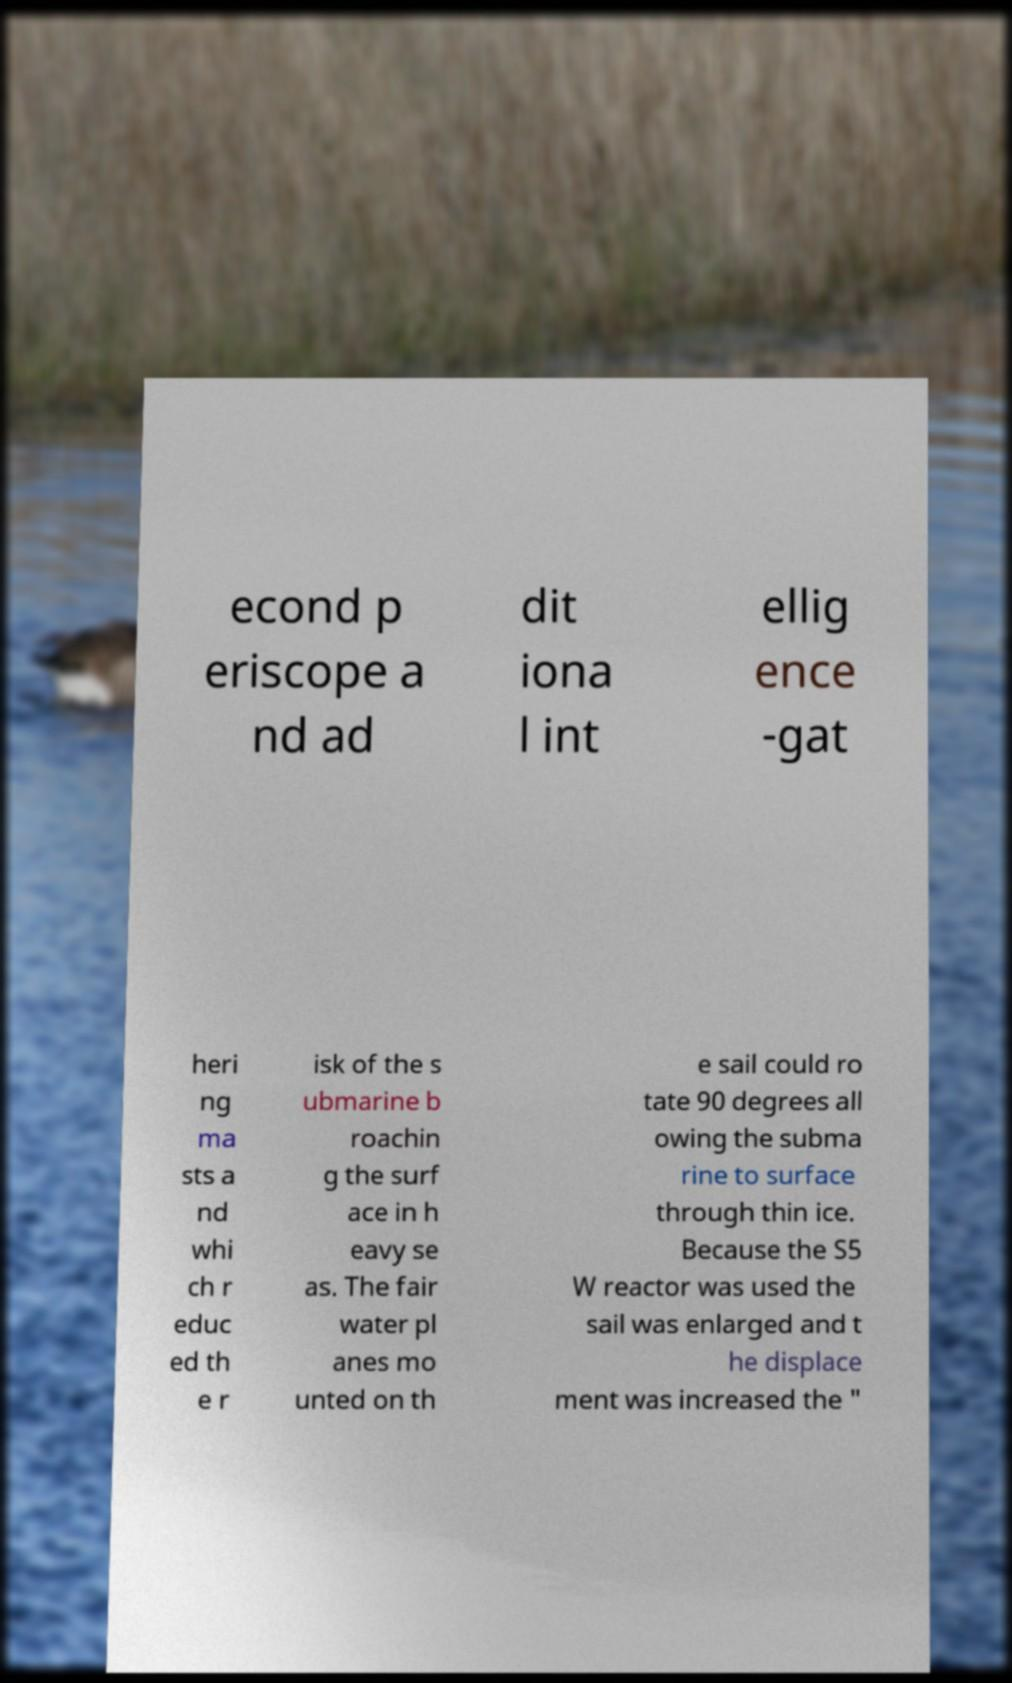Please read and relay the text visible in this image. What does it say? econd p eriscope a nd ad dit iona l int ellig ence -gat heri ng ma sts a nd whi ch r educ ed th e r isk of the s ubmarine b roachin g the surf ace in h eavy se as. The fair water pl anes mo unted on th e sail could ro tate 90 degrees all owing the subma rine to surface through thin ice. Because the S5 W reactor was used the sail was enlarged and t he displace ment was increased the " 